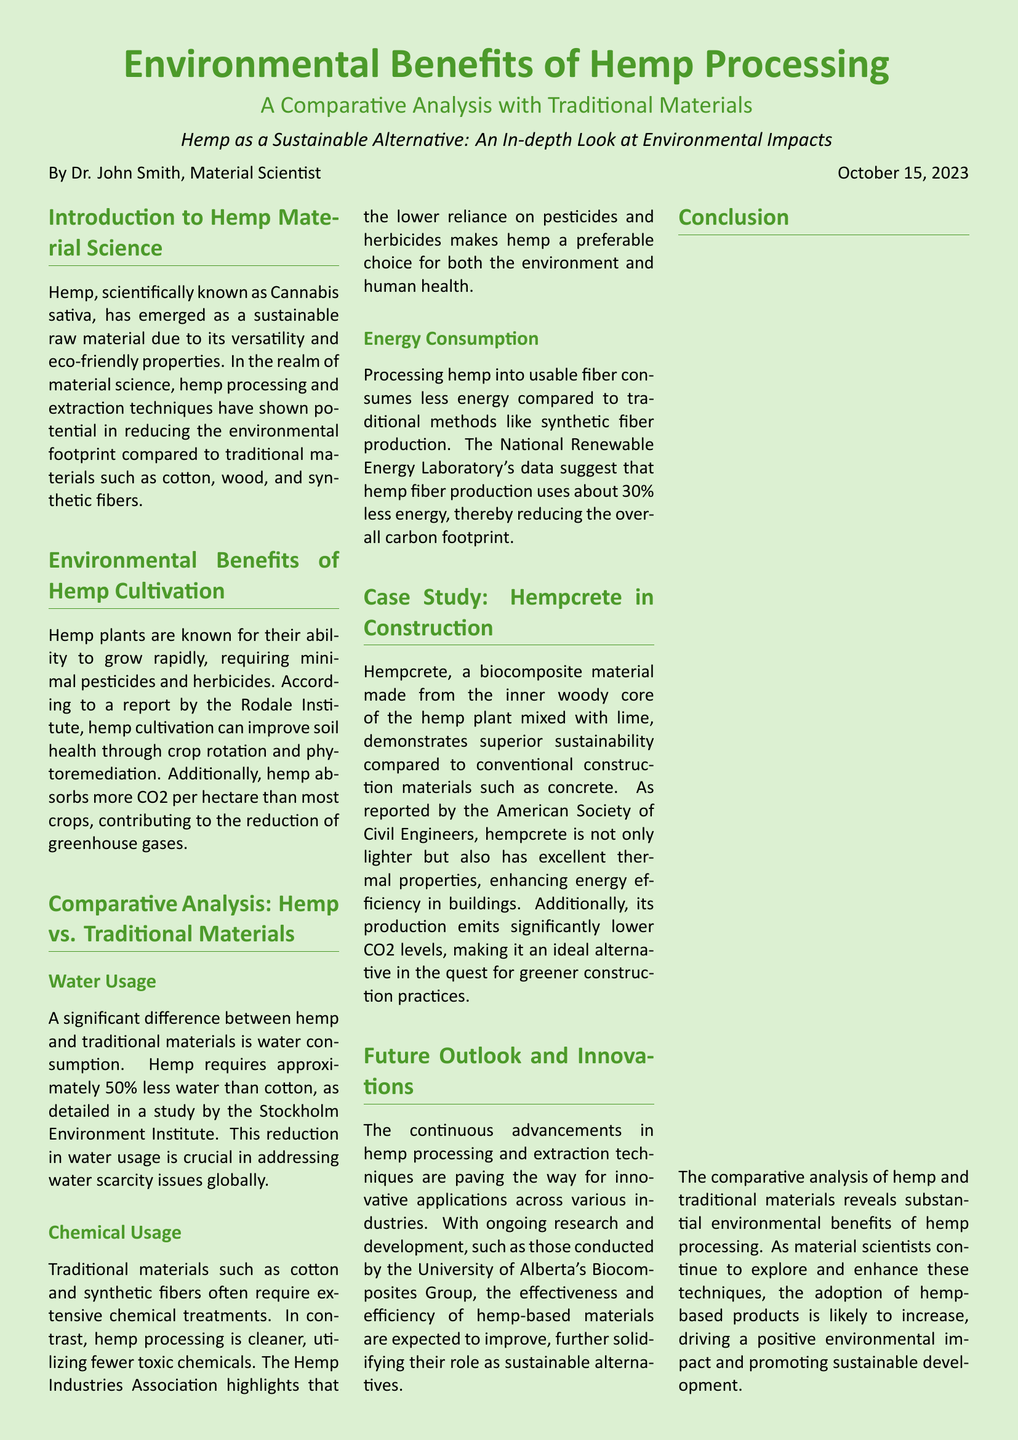What is the scientific name of hemp? The scientific name of hemp is given in the introduction as Cannabis sativa.
Answer: Cannabis sativa Who authored the document? The author is mentioned at the end of the introduction section as Dr. John Smith.
Answer: Dr. John Smith What is the date of publication? The publication date is specified in the introduction as October 15, 2023.
Answer: October 15, 2023 How much less water does hemp require compared to cotton? The document states that hemp requires approximately 50% less water than cotton.
Answer: 50% What percentage less energy is consumed in hemp fiber production compared to synthetic fiber production? As stated in the document, hemp fiber production uses about 30% less energy.
Answer: 30% What material is hempcrete made from? The document specifies that hempcrete is made from the inner woody core of the hemp plant mixed with lime.
Answer: Inner woody core of the hemp plant mixed with lime What organization reported the benefits of hempcrete? The American Society of Civil Engineers is mentioned in connection with the benefits of hempcrete.
Answer: American Society of Civil Engineers What is a key environmental benefit of hemp cultivation mentioned in the document? The document highlights that hemp cultivation can improve soil health through crop rotation and phytoremediation.
Answer: Soil health improvement What type of material is emphasized in the future outlook section? The future outlook discusses the advancements in hemp processing and extraction techniques.
Answer: Hemp processing and extraction techniques 